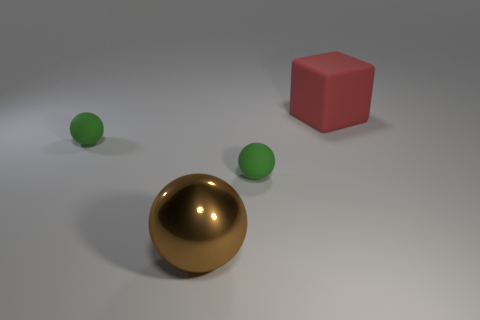Subtract all big spheres. How many spheres are left? 2 Subtract all green cylinders. How many green balls are left? 2 Add 4 small green balls. How many objects exist? 8 Subtract all cubes. How many objects are left? 3 Add 3 small spheres. How many small spheres exist? 5 Subtract 0 cyan cylinders. How many objects are left? 4 Subtract all cyan spheres. Subtract all brown blocks. How many spheres are left? 3 Subtract all green shiny objects. Subtract all red matte things. How many objects are left? 3 Add 4 red rubber things. How many red rubber things are left? 5 